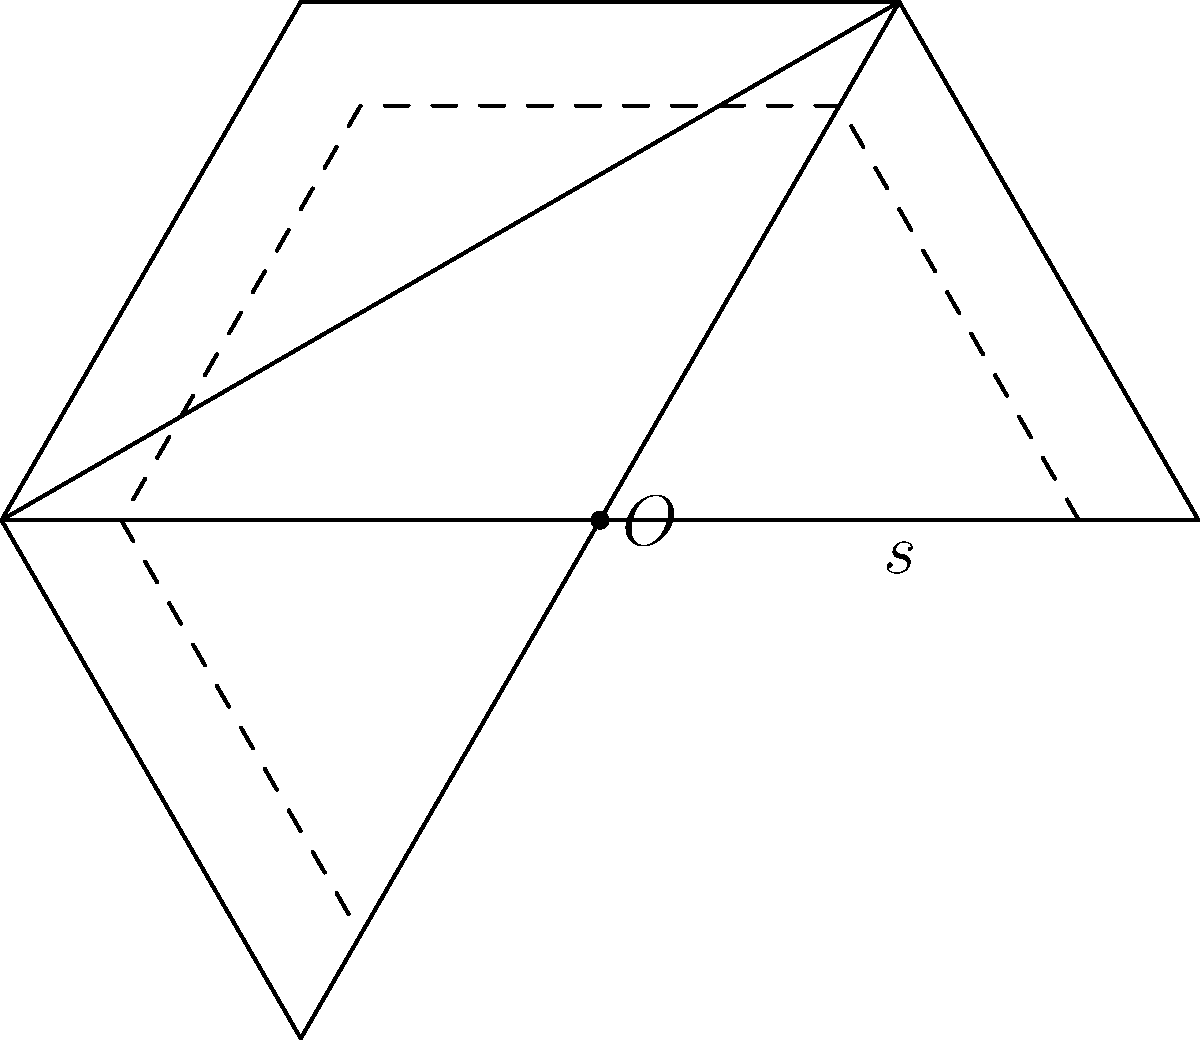In Stian Johansen's latest geometric exploration, he presents a regular hexagon with side length $s$. If the area of the hexagon is increased by 44%, what is the percentage increase in the side length? Round your answer to the nearest whole number. Let's approach this step-by-step:

1) The area of a regular hexagon with side length $s$ is given by:

   $$A = \frac{3\sqrt{3}}{2}s^2$$

2) Let's say the new side length is $x$. The new area is 44% larger, so:

   $$1.44A = \frac{3\sqrt{3}}{2}x^2$$

3) We can set up an equation:

   $$1.44 \cdot \frac{3\sqrt{3}}{2}s^2 = \frac{3\sqrt{3}}{2}x^2$$

4) Simplify:

   $$1.44s^2 = x^2$$

5) Take the square root of both sides:

   $$\sqrt{1.44}s = x$$
   $$1.2s = x$$

6) This means the new side length is 1.2 times the original side length.

7) To calculate the percentage increase:

   $$(1.2 - 1) \times 100\% = 0.2 \times 100\% = 20\%$$

8) Rounding to the nearest whole number gives us 20%.

This problem reflects Johansen's interest in geometric transformations and their effects on area and length, a theme often explored in Norwegian mathematics education.
Answer: 20% 